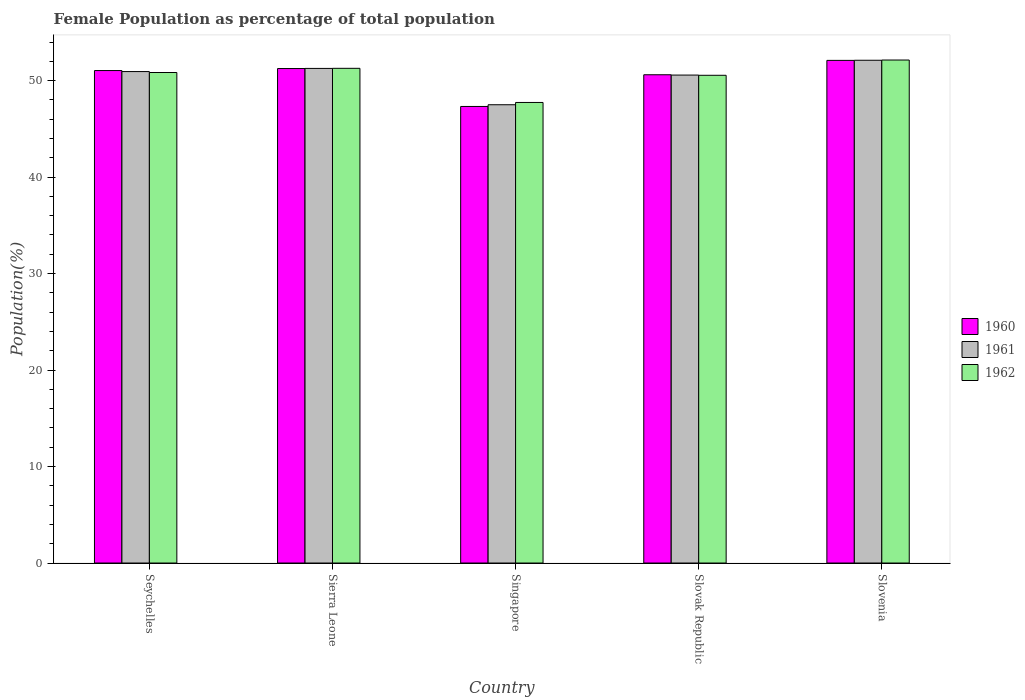How many bars are there on the 1st tick from the left?
Your answer should be very brief. 3. How many bars are there on the 2nd tick from the right?
Your answer should be very brief. 3. What is the label of the 4th group of bars from the left?
Provide a succinct answer. Slovak Republic. What is the female population in in 1961 in Slovenia?
Give a very brief answer. 52.11. Across all countries, what is the maximum female population in in 1962?
Your answer should be compact. 52.13. Across all countries, what is the minimum female population in in 1962?
Ensure brevity in your answer.  47.74. In which country was the female population in in 1962 maximum?
Offer a very short reply. Slovenia. In which country was the female population in in 1960 minimum?
Give a very brief answer. Singapore. What is the total female population in in 1962 in the graph?
Make the answer very short. 252.53. What is the difference between the female population in in 1961 in Seychelles and that in Slovak Republic?
Your response must be concise. 0.36. What is the difference between the female population in in 1962 in Slovenia and the female population in in 1960 in Singapore?
Provide a succinct answer. 4.81. What is the average female population in in 1960 per country?
Make the answer very short. 50.46. What is the difference between the female population in of/in 1962 and female population in of/in 1961 in Slovenia?
Give a very brief answer. 0.02. What is the ratio of the female population in in 1961 in Sierra Leone to that in Slovak Republic?
Give a very brief answer. 1.01. Is the female population in in 1962 in Sierra Leone less than that in Singapore?
Your response must be concise. No. What is the difference between the highest and the second highest female population in in 1960?
Provide a short and direct response. -0.21. What is the difference between the highest and the lowest female population in in 1960?
Provide a succinct answer. 4.77. Are all the bars in the graph horizontal?
Offer a very short reply. No. How many countries are there in the graph?
Give a very brief answer. 5. Are the values on the major ticks of Y-axis written in scientific E-notation?
Ensure brevity in your answer.  No. Does the graph contain any zero values?
Ensure brevity in your answer.  No. Does the graph contain grids?
Offer a terse response. No. Where does the legend appear in the graph?
Provide a succinct answer. Center right. How are the legend labels stacked?
Your response must be concise. Vertical. What is the title of the graph?
Offer a very short reply. Female Population as percentage of total population. What is the label or title of the Y-axis?
Ensure brevity in your answer.  Population(%). What is the Population(%) of 1960 in Seychelles?
Offer a very short reply. 51.04. What is the Population(%) of 1961 in Seychelles?
Make the answer very short. 50.94. What is the Population(%) in 1962 in Seychelles?
Offer a terse response. 50.84. What is the Population(%) in 1960 in Sierra Leone?
Offer a very short reply. 51.25. What is the Population(%) of 1961 in Sierra Leone?
Your answer should be compact. 51.26. What is the Population(%) in 1962 in Sierra Leone?
Provide a short and direct response. 51.27. What is the Population(%) of 1960 in Singapore?
Provide a succinct answer. 47.32. What is the Population(%) of 1961 in Singapore?
Offer a very short reply. 47.5. What is the Population(%) in 1962 in Singapore?
Offer a very short reply. 47.74. What is the Population(%) of 1960 in Slovak Republic?
Ensure brevity in your answer.  50.61. What is the Population(%) in 1961 in Slovak Republic?
Your answer should be compact. 50.57. What is the Population(%) of 1962 in Slovak Republic?
Ensure brevity in your answer.  50.55. What is the Population(%) in 1960 in Slovenia?
Offer a terse response. 52.1. What is the Population(%) of 1961 in Slovenia?
Your answer should be compact. 52.11. What is the Population(%) of 1962 in Slovenia?
Your answer should be compact. 52.13. Across all countries, what is the maximum Population(%) in 1960?
Provide a short and direct response. 52.1. Across all countries, what is the maximum Population(%) of 1961?
Offer a very short reply. 52.11. Across all countries, what is the maximum Population(%) of 1962?
Your answer should be very brief. 52.13. Across all countries, what is the minimum Population(%) of 1960?
Keep it short and to the point. 47.32. Across all countries, what is the minimum Population(%) of 1961?
Ensure brevity in your answer.  47.5. Across all countries, what is the minimum Population(%) of 1962?
Your answer should be compact. 47.74. What is the total Population(%) of 1960 in the graph?
Offer a terse response. 252.31. What is the total Population(%) of 1961 in the graph?
Offer a terse response. 252.38. What is the total Population(%) in 1962 in the graph?
Provide a succinct answer. 252.53. What is the difference between the Population(%) of 1960 in Seychelles and that in Sierra Leone?
Offer a very short reply. -0.21. What is the difference between the Population(%) of 1961 in Seychelles and that in Sierra Leone?
Offer a very short reply. -0.33. What is the difference between the Population(%) of 1962 in Seychelles and that in Sierra Leone?
Your response must be concise. -0.43. What is the difference between the Population(%) in 1960 in Seychelles and that in Singapore?
Offer a very short reply. 3.72. What is the difference between the Population(%) in 1961 in Seychelles and that in Singapore?
Offer a very short reply. 3.44. What is the difference between the Population(%) in 1962 in Seychelles and that in Singapore?
Your response must be concise. 3.1. What is the difference between the Population(%) in 1960 in Seychelles and that in Slovak Republic?
Provide a short and direct response. 0.44. What is the difference between the Population(%) in 1961 in Seychelles and that in Slovak Republic?
Your answer should be very brief. 0.36. What is the difference between the Population(%) of 1962 in Seychelles and that in Slovak Republic?
Provide a succinct answer. 0.29. What is the difference between the Population(%) in 1960 in Seychelles and that in Slovenia?
Provide a short and direct response. -1.05. What is the difference between the Population(%) of 1961 in Seychelles and that in Slovenia?
Provide a short and direct response. -1.17. What is the difference between the Population(%) in 1962 in Seychelles and that in Slovenia?
Provide a short and direct response. -1.29. What is the difference between the Population(%) in 1960 in Sierra Leone and that in Singapore?
Your answer should be very brief. 3.93. What is the difference between the Population(%) of 1961 in Sierra Leone and that in Singapore?
Your response must be concise. 3.76. What is the difference between the Population(%) of 1962 in Sierra Leone and that in Singapore?
Offer a very short reply. 3.54. What is the difference between the Population(%) in 1960 in Sierra Leone and that in Slovak Republic?
Give a very brief answer. 0.65. What is the difference between the Population(%) of 1961 in Sierra Leone and that in Slovak Republic?
Your answer should be very brief. 0.69. What is the difference between the Population(%) in 1962 in Sierra Leone and that in Slovak Republic?
Keep it short and to the point. 0.72. What is the difference between the Population(%) of 1960 in Sierra Leone and that in Slovenia?
Give a very brief answer. -0.84. What is the difference between the Population(%) of 1961 in Sierra Leone and that in Slovenia?
Make the answer very short. -0.84. What is the difference between the Population(%) of 1962 in Sierra Leone and that in Slovenia?
Your response must be concise. -0.86. What is the difference between the Population(%) of 1960 in Singapore and that in Slovak Republic?
Offer a very short reply. -3.28. What is the difference between the Population(%) in 1961 in Singapore and that in Slovak Republic?
Keep it short and to the point. -3.07. What is the difference between the Population(%) of 1962 in Singapore and that in Slovak Republic?
Provide a succinct answer. -2.82. What is the difference between the Population(%) in 1960 in Singapore and that in Slovenia?
Offer a terse response. -4.77. What is the difference between the Population(%) of 1961 in Singapore and that in Slovenia?
Give a very brief answer. -4.61. What is the difference between the Population(%) of 1962 in Singapore and that in Slovenia?
Your response must be concise. -4.4. What is the difference between the Population(%) in 1960 in Slovak Republic and that in Slovenia?
Offer a terse response. -1.49. What is the difference between the Population(%) of 1961 in Slovak Republic and that in Slovenia?
Offer a terse response. -1.53. What is the difference between the Population(%) of 1962 in Slovak Republic and that in Slovenia?
Make the answer very short. -1.58. What is the difference between the Population(%) of 1960 in Seychelles and the Population(%) of 1961 in Sierra Leone?
Your answer should be very brief. -0.22. What is the difference between the Population(%) of 1960 in Seychelles and the Population(%) of 1962 in Sierra Leone?
Make the answer very short. -0.23. What is the difference between the Population(%) of 1961 in Seychelles and the Population(%) of 1962 in Sierra Leone?
Offer a very short reply. -0.34. What is the difference between the Population(%) of 1960 in Seychelles and the Population(%) of 1961 in Singapore?
Make the answer very short. 3.54. What is the difference between the Population(%) in 1960 in Seychelles and the Population(%) in 1962 in Singapore?
Offer a very short reply. 3.31. What is the difference between the Population(%) in 1961 in Seychelles and the Population(%) in 1962 in Singapore?
Your answer should be compact. 3.2. What is the difference between the Population(%) in 1960 in Seychelles and the Population(%) in 1961 in Slovak Republic?
Give a very brief answer. 0.47. What is the difference between the Population(%) of 1960 in Seychelles and the Population(%) of 1962 in Slovak Republic?
Your answer should be very brief. 0.49. What is the difference between the Population(%) in 1961 in Seychelles and the Population(%) in 1962 in Slovak Republic?
Keep it short and to the point. 0.39. What is the difference between the Population(%) of 1960 in Seychelles and the Population(%) of 1961 in Slovenia?
Provide a succinct answer. -1.07. What is the difference between the Population(%) in 1960 in Seychelles and the Population(%) in 1962 in Slovenia?
Your answer should be very brief. -1.09. What is the difference between the Population(%) of 1961 in Seychelles and the Population(%) of 1962 in Slovenia?
Ensure brevity in your answer.  -1.2. What is the difference between the Population(%) of 1960 in Sierra Leone and the Population(%) of 1961 in Singapore?
Your answer should be compact. 3.75. What is the difference between the Population(%) of 1960 in Sierra Leone and the Population(%) of 1962 in Singapore?
Offer a terse response. 3.52. What is the difference between the Population(%) of 1961 in Sierra Leone and the Population(%) of 1962 in Singapore?
Give a very brief answer. 3.53. What is the difference between the Population(%) in 1960 in Sierra Leone and the Population(%) in 1961 in Slovak Republic?
Your answer should be compact. 0.68. What is the difference between the Population(%) in 1960 in Sierra Leone and the Population(%) in 1962 in Slovak Republic?
Ensure brevity in your answer.  0.7. What is the difference between the Population(%) in 1961 in Sierra Leone and the Population(%) in 1962 in Slovak Republic?
Your answer should be very brief. 0.71. What is the difference between the Population(%) of 1960 in Sierra Leone and the Population(%) of 1961 in Slovenia?
Offer a very short reply. -0.86. What is the difference between the Population(%) in 1960 in Sierra Leone and the Population(%) in 1962 in Slovenia?
Your answer should be compact. -0.88. What is the difference between the Population(%) in 1961 in Sierra Leone and the Population(%) in 1962 in Slovenia?
Provide a short and direct response. -0.87. What is the difference between the Population(%) of 1960 in Singapore and the Population(%) of 1961 in Slovak Republic?
Your answer should be very brief. -3.25. What is the difference between the Population(%) of 1960 in Singapore and the Population(%) of 1962 in Slovak Republic?
Ensure brevity in your answer.  -3.23. What is the difference between the Population(%) in 1961 in Singapore and the Population(%) in 1962 in Slovak Republic?
Offer a terse response. -3.05. What is the difference between the Population(%) in 1960 in Singapore and the Population(%) in 1961 in Slovenia?
Provide a succinct answer. -4.79. What is the difference between the Population(%) in 1960 in Singapore and the Population(%) in 1962 in Slovenia?
Offer a very short reply. -4.81. What is the difference between the Population(%) in 1961 in Singapore and the Population(%) in 1962 in Slovenia?
Offer a terse response. -4.63. What is the difference between the Population(%) of 1960 in Slovak Republic and the Population(%) of 1961 in Slovenia?
Ensure brevity in your answer.  -1.5. What is the difference between the Population(%) in 1960 in Slovak Republic and the Population(%) in 1962 in Slovenia?
Provide a succinct answer. -1.53. What is the difference between the Population(%) of 1961 in Slovak Republic and the Population(%) of 1962 in Slovenia?
Offer a terse response. -1.56. What is the average Population(%) of 1960 per country?
Your answer should be very brief. 50.46. What is the average Population(%) in 1961 per country?
Provide a succinct answer. 50.48. What is the average Population(%) in 1962 per country?
Give a very brief answer. 50.51. What is the difference between the Population(%) in 1960 and Population(%) in 1961 in Seychelles?
Give a very brief answer. 0.11. What is the difference between the Population(%) of 1960 and Population(%) of 1962 in Seychelles?
Ensure brevity in your answer.  0.2. What is the difference between the Population(%) of 1961 and Population(%) of 1962 in Seychelles?
Your response must be concise. 0.1. What is the difference between the Population(%) of 1960 and Population(%) of 1961 in Sierra Leone?
Your response must be concise. -0.01. What is the difference between the Population(%) of 1960 and Population(%) of 1962 in Sierra Leone?
Give a very brief answer. -0.02. What is the difference between the Population(%) of 1961 and Population(%) of 1962 in Sierra Leone?
Your response must be concise. -0.01. What is the difference between the Population(%) in 1960 and Population(%) in 1961 in Singapore?
Make the answer very short. -0.18. What is the difference between the Population(%) of 1960 and Population(%) of 1962 in Singapore?
Provide a short and direct response. -0.41. What is the difference between the Population(%) of 1961 and Population(%) of 1962 in Singapore?
Your answer should be compact. -0.24. What is the difference between the Population(%) in 1960 and Population(%) in 1961 in Slovak Republic?
Provide a short and direct response. 0.03. What is the difference between the Population(%) of 1960 and Population(%) of 1962 in Slovak Republic?
Provide a short and direct response. 0.05. What is the difference between the Population(%) of 1961 and Population(%) of 1962 in Slovak Republic?
Provide a succinct answer. 0.02. What is the difference between the Population(%) of 1960 and Population(%) of 1961 in Slovenia?
Ensure brevity in your answer.  -0.01. What is the difference between the Population(%) of 1960 and Population(%) of 1962 in Slovenia?
Offer a terse response. -0.04. What is the difference between the Population(%) of 1961 and Population(%) of 1962 in Slovenia?
Keep it short and to the point. -0.02. What is the ratio of the Population(%) in 1961 in Seychelles to that in Sierra Leone?
Make the answer very short. 0.99. What is the ratio of the Population(%) in 1962 in Seychelles to that in Sierra Leone?
Your answer should be very brief. 0.99. What is the ratio of the Population(%) in 1960 in Seychelles to that in Singapore?
Make the answer very short. 1.08. What is the ratio of the Population(%) in 1961 in Seychelles to that in Singapore?
Keep it short and to the point. 1.07. What is the ratio of the Population(%) in 1962 in Seychelles to that in Singapore?
Make the answer very short. 1.06. What is the ratio of the Population(%) of 1960 in Seychelles to that in Slovak Republic?
Provide a succinct answer. 1.01. What is the ratio of the Population(%) of 1962 in Seychelles to that in Slovak Republic?
Provide a succinct answer. 1.01. What is the ratio of the Population(%) of 1960 in Seychelles to that in Slovenia?
Keep it short and to the point. 0.98. What is the ratio of the Population(%) in 1961 in Seychelles to that in Slovenia?
Offer a terse response. 0.98. What is the ratio of the Population(%) of 1962 in Seychelles to that in Slovenia?
Make the answer very short. 0.98. What is the ratio of the Population(%) in 1960 in Sierra Leone to that in Singapore?
Provide a succinct answer. 1.08. What is the ratio of the Population(%) of 1961 in Sierra Leone to that in Singapore?
Your answer should be very brief. 1.08. What is the ratio of the Population(%) of 1962 in Sierra Leone to that in Singapore?
Offer a very short reply. 1.07. What is the ratio of the Population(%) of 1960 in Sierra Leone to that in Slovak Republic?
Offer a very short reply. 1.01. What is the ratio of the Population(%) in 1961 in Sierra Leone to that in Slovak Republic?
Offer a terse response. 1.01. What is the ratio of the Population(%) of 1962 in Sierra Leone to that in Slovak Republic?
Provide a short and direct response. 1.01. What is the ratio of the Population(%) of 1960 in Sierra Leone to that in Slovenia?
Offer a terse response. 0.98. What is the ratio of the Population(%) in 1961 in Sierra Leone to that in Slovenia?
Your answer should be very brief. 0.98. What is the ratio of the Population(%) in 1962 in Sierra Leone to that in Slovenia?
Your response must be concise. 0.98. What is the ratio of the Population(%) of 1960 in Singapore to that in Slovak Republic?
Your answer should be very brief. 0.94. What is the ratio of the Population(%) in 1961 in Singapore to that in Slovak Republic?
Give a very brief answer. 0.94. What is the ratio of the Population(%) in 1962 in Singapore to that in Slovak Republic?
Your answer should be compact. 0.94. What is the ratio of the Population(%) of 1960 in Singapore to that in Slovenia?
Provide a succinct answer. 0.91. What is the ratio of the Population(%) of 1961 in Singapore to that in Slovenia?
Your response must be concise. 0.91. What is the ratio of the Population(%) in 1962 in Singapore to that in Slovenia?
Your answer should be very brief. 0.92. What is the ratio of the Population(%) of 1960 in Slovak Republic to that in Slovenia?
Provide a short and direct response. 0.97. What is the ratio of the Population(%) in 1961 in Slovak Republic to that in Slovenia?
Offer a very short reply. 0.97. What is the ratio of the Population(%) of 1962 in Slovak Republic to that in Slovenia?
Your answer should be very brief. 0.97. What is the difference between the highest and the second highest Population(%) in 1960?
Ensure brevity in your answer.  0.84. What is the difference between the highest and the second highest Population(%) of 1961?
Provide a short and direct response. 0.84. What is the difference between the highest and the second highest Population(%) in 1962?
Provide a short and direct response. 0.86. What is the difference between the highest and the lowest Population(%) of 1960?
Your answer should be compact. 4.77. What is the difference between the highest and the lowest Population(%) in 1961?
Your response must be concise. 4.61. What is the difference between the highest and the lowest Population(%) in 1962?
Your answer should be very brief. 4.4. 